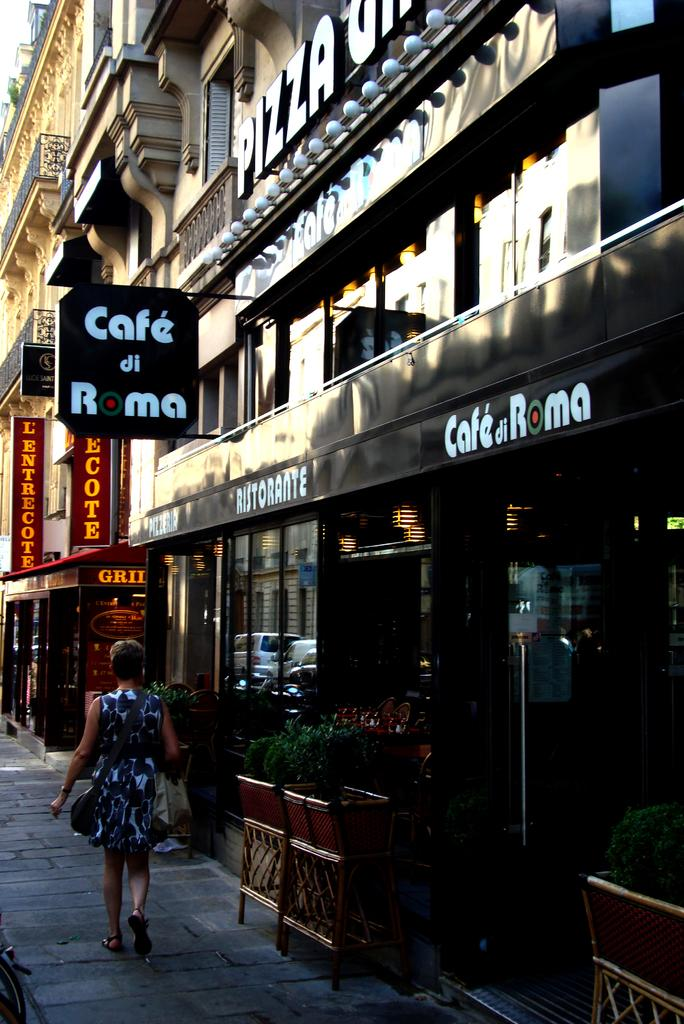What is located in the center of the image? There are buildings and boards in the center of the image. What can be found at the bottom of the image? There are flower pots and plants at the bottom of the image. What type of doors are present in the image? There are glass doors in the image. What is the woman in the image doing? A woman is walking in the image. What type of whip is the woman holding in the image? There is no whip present in the image; the woman is simply walking. How many apples are on the tree in the image? There is no tree or apple present in the image. What is the woman's mother doing in the image? There is no mention of the woman's mother in the image, only the woman herself. 